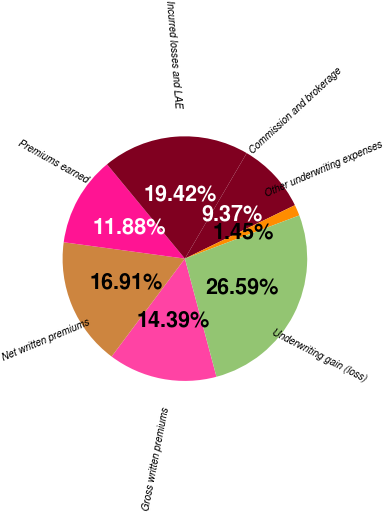<chart> <loc_0><loc_0><loc_500><loc_500><pie_chart><fcel>Gross written premiums<fcel>Net written premiums<fcel>Premiums earned<fcel>Incurred losses and LAE<fcel>Commission and brokerage<fcel>Other underwriting expenses<fcel>Underwriting gain (loss)<nl><fcel>14.39%<fcel>16.91%<fcel>11.88%<fcel>19.42%<fcel>9.37%<fcel>1.45%<fcel>26.59%<nl></chart> 